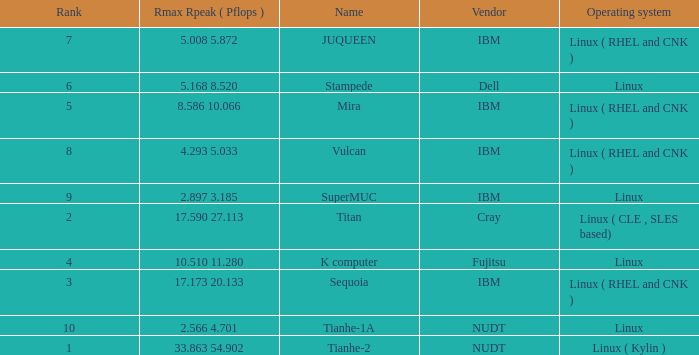What is the rank of Rmax Rpeak ( Pflops ) of 17.173 20.133? 3.0. 